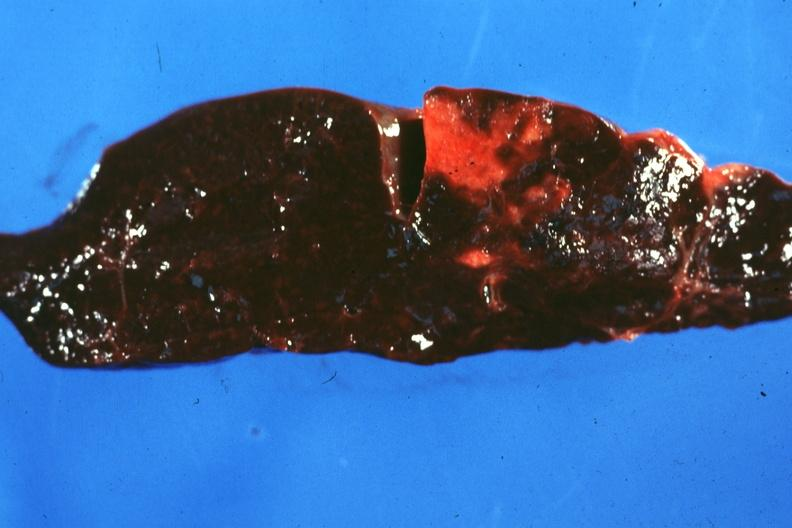what is present?
Answer the question using a single word or phrase. Infarct 